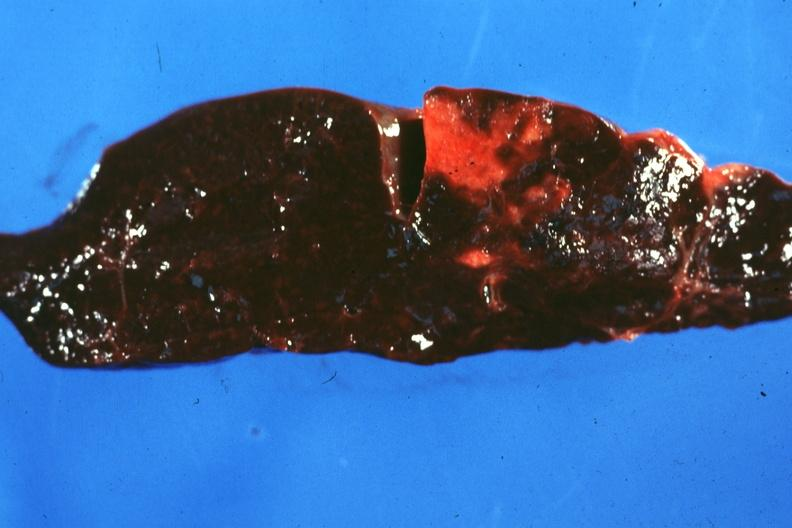what is present?
Answer the question using a single word or phrase. Infarct 